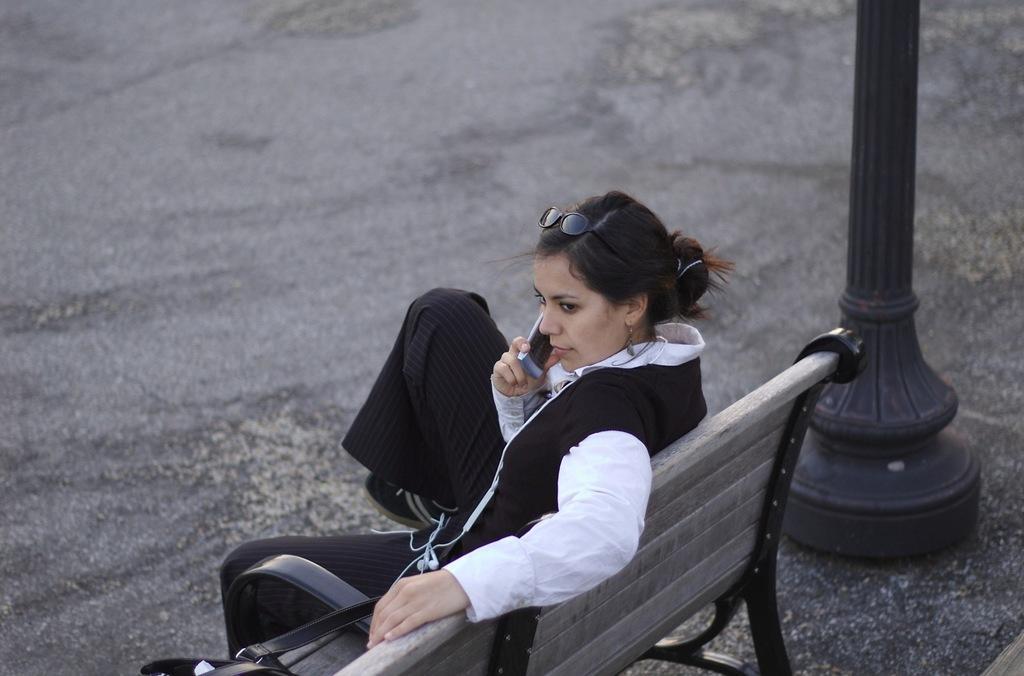Can you describe this image briefly? In this picture we can see a woman sitting on a bench on the ground, she is holding a mobile, here we can see a pole. 